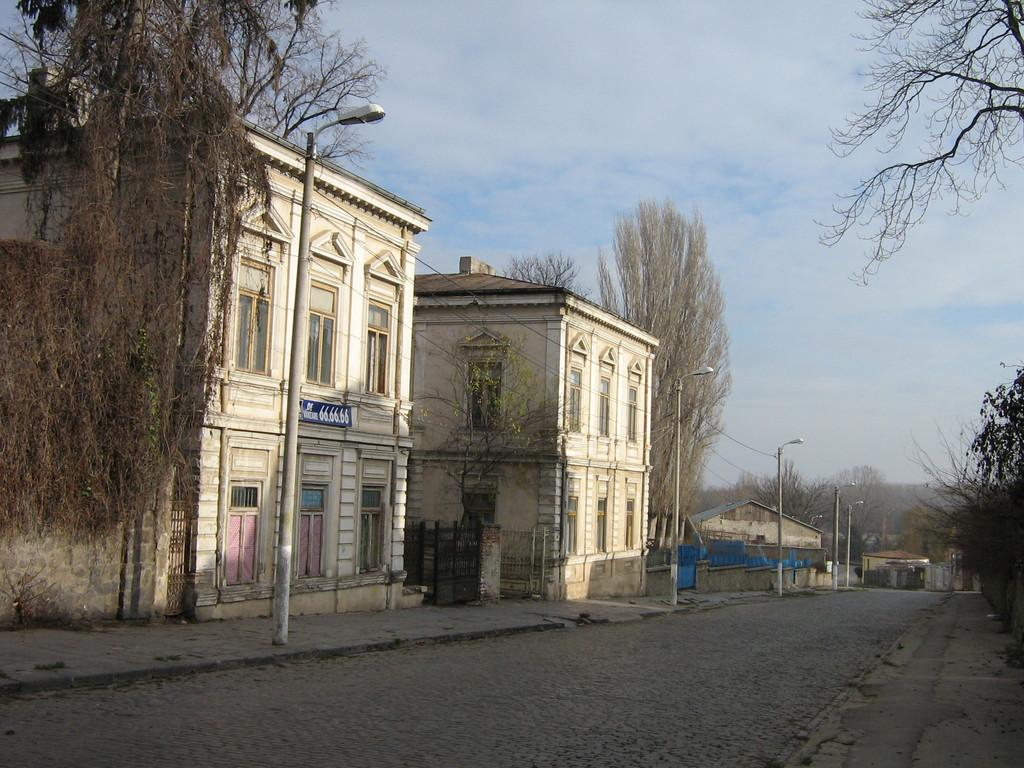What is the main feature of the image? There is a road in the image. What is present alongside the road? There is a footpath on either side of the road. What structures are visible in the image? There are light poles and buildings in the image. What type of vegetation can be seen in the image? There are trees in the image. What is visible at the top of the image? The sky is blue and visible at the top of the image. What condition is the suit in the image? There is no suit present in the image. What book is being read by the tree in the image? There are no books or trees reading in the image. 